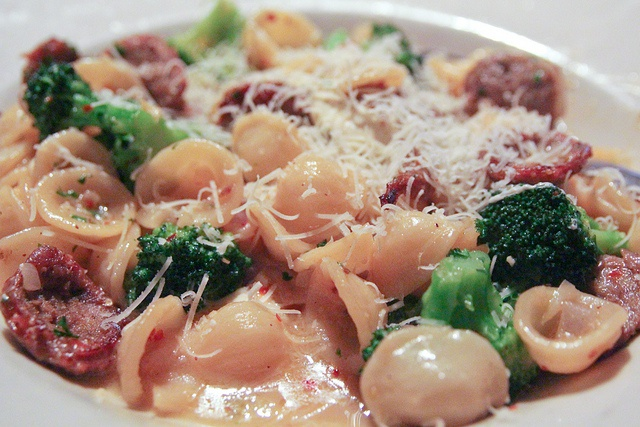Describe the objects in this image and their specific colors. I can see broccoli in lightgray, black, teal, darkgreen, and gray tones, broccoli in lightgray, black, darkgreen, and green tones, broccoli in lightgray, black, darkgray, darkgreen, and gray tones, and broccoli in lightgray, darkgreen, green, and black tones in this image. 